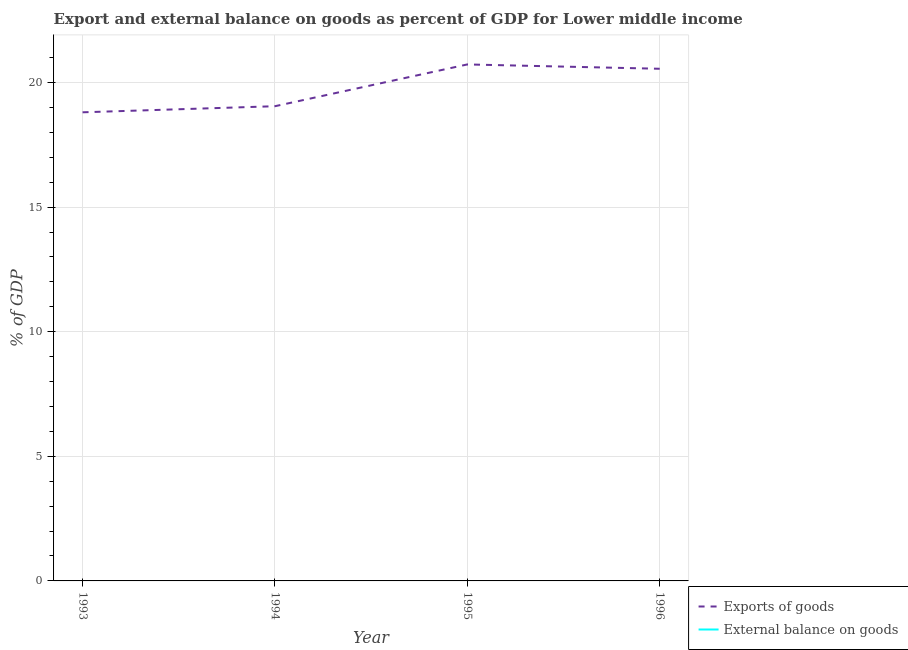What is the export of goods as percentage of gdp in 1994?
Ensure brevity in your answer.  19.05. Across all years, what is the minimum export of goods as percentage of gdp?
Ensure brevity in your answer.  18.8. In which year was the export of goods as percentage of gdp maximum?
Your response must be concise. 1995. What is the difference between the export of goods as percentage of gdp in 1994 and that in 1996?
Offer a terse response. -1.5. What is the difference between the external balance on goods as percentage of gdp in 1994 and the export of goods as percentage of gdp in 1993?
Your answer should be compact. -18.8. In how many years, is the export of goods as percentage of gdp greater than 4 %?
Give a very brief answer. 4. What is the ratio of the export of goods as percentage of gdp in 1993 to that in 1995?
Ensure brevity in your answer.  0.91. Is the export of goods as percentage of gdp in 1995 less than that in 1996?
Your answer should be very brief. No. What is the difference between the highest and the second highest export of goods as percentage of gdp?
Offer a terse response. 0.17. What is the difference between the highest and the lowest export of goods as percentage of gdp?
Offer a terse response. 1.92. In how many years, is the export of goods as percentage of gdp greater than the average export of goods as percentage of gdp taken over all years?
Offer a very short reply. 2. Does the external balance on goods as percentage of gdp monotonically increase over the years?
Give a very brief answer. No. Is the external balance on goods as percentage of gdp strictly greater than the export of goods as percentage of gdp over the years?
Your answer should be compact. No. What is the difference between two consecutive major ticks on the Y-axis?
Ensure brevity in your answer.  5. Are the values on the major ticks of Y-axis written in scientific E-notation?
Give a very brief answer. No. Does the graph contain grids?
Your answer should be very brief. Yes. Where does the legend appear in the graph?
Offer a terse response. Bottom right. How many legend labels are there?
Your response must be concise. 2. How are the legend labels stacked?
Your response must be concise. Vertical. What is the title of the graph?
Your answer should be very brief. Export and external balance on goods as percent of GDP for Lower middle income. Does "2012 US$" appear as one of the legend labels in the graph?
Make the answer very short. No. What is the label or title of the X-axis?
Ensure brevity in your answer.  Year. What is the label or title of the Y-axis?
Offer a terse response. % of GDP. What is the % of GDP of Exports of goods in 1993?
Your answer should be very brief. 18.8. What is the % of GDP in External balance on goods in 1993?
Make the answer very short. 0. What is the % of GDP of Exports of goods in 1994?
Keep it short and to the point. 19.05. What is the % of GDP of Exports of goods in 1995?
Offer a very short reply. 20.72. What is the % of GDP of Exports of goods in 1996?
Keep it short and to the point. 20.55. Across all years, what is the maximum % of GDP of Exports of goods?
Your answer should be compact. 20.72. Across all years, what is the minimum % of GDP of Exports of goods?
Offer a very short reply. 18.8. What is the total % of GDP in Exports of goods in the graph?
Provide a short and direct response. 79.13. What is the total % of GDP in External balance on goods in the graph?
Your response must be concise. 0. What is the difference between the % of GDP in Exports of goods in 1993 and that in 1994?
Ensure brevity in your answer.  -0.24. What is the difference between the % of GDP of Exports of goods in 1993 and that in 1995?
Make the answer very short. -1.92. What is the difference between the % of GDP of Exports of goods in 1993 and that in 1996?
Your response must be concise. -1.75. What is the difference between the % of GDP of Exports of goods in 1994 and that in 1995?
Give a very brief answer. -1.68. What is the difference between the % of GDP in Exports of goods in 1994 and that in 1996?
Provide a short and direct response. -1.5. What is the difference between the % of GDP of Exports of goods in 1995 and that in 1996?
Provide a short and direct response. 0.17. What is the average % of GDP of Exports of goods per year?
Ensure brevity in your answer.  19.78. What is the ratio of the % of GDP in Exports of goods in 1993 to that in 1994?
Your response must be concise. 0.99. What is the ratio of the % of GDP in Exports of goods in 1993 to that in 1995?
Your answer should be very brief. 0.91. What is the ratio of the % of GDP in Exports of goods in 1993 to that in 1996?
Your answer should be compact. 0.92. What is the ratio of the % of GDP in Exports of goods in 1994 to that in 1995?
Ensure brevity in your answer.  0.92. What is the ratio of the % of GDP in Exports of goods in 1994 to that in 1996?
Offer a very short reply. 0.93. What is the ratio of the % of GDP in Exports of goods in 1995 to that in 1996?
Your answer should be very brief. 1.01. What is the difference between the highest and the second highest % of GDP in Exports of goods?
Make the answer very short. 0.17. What is the difference between the highest and the lowest % of GDP in Exports of goods?
Offer a terse response. 1.92. 